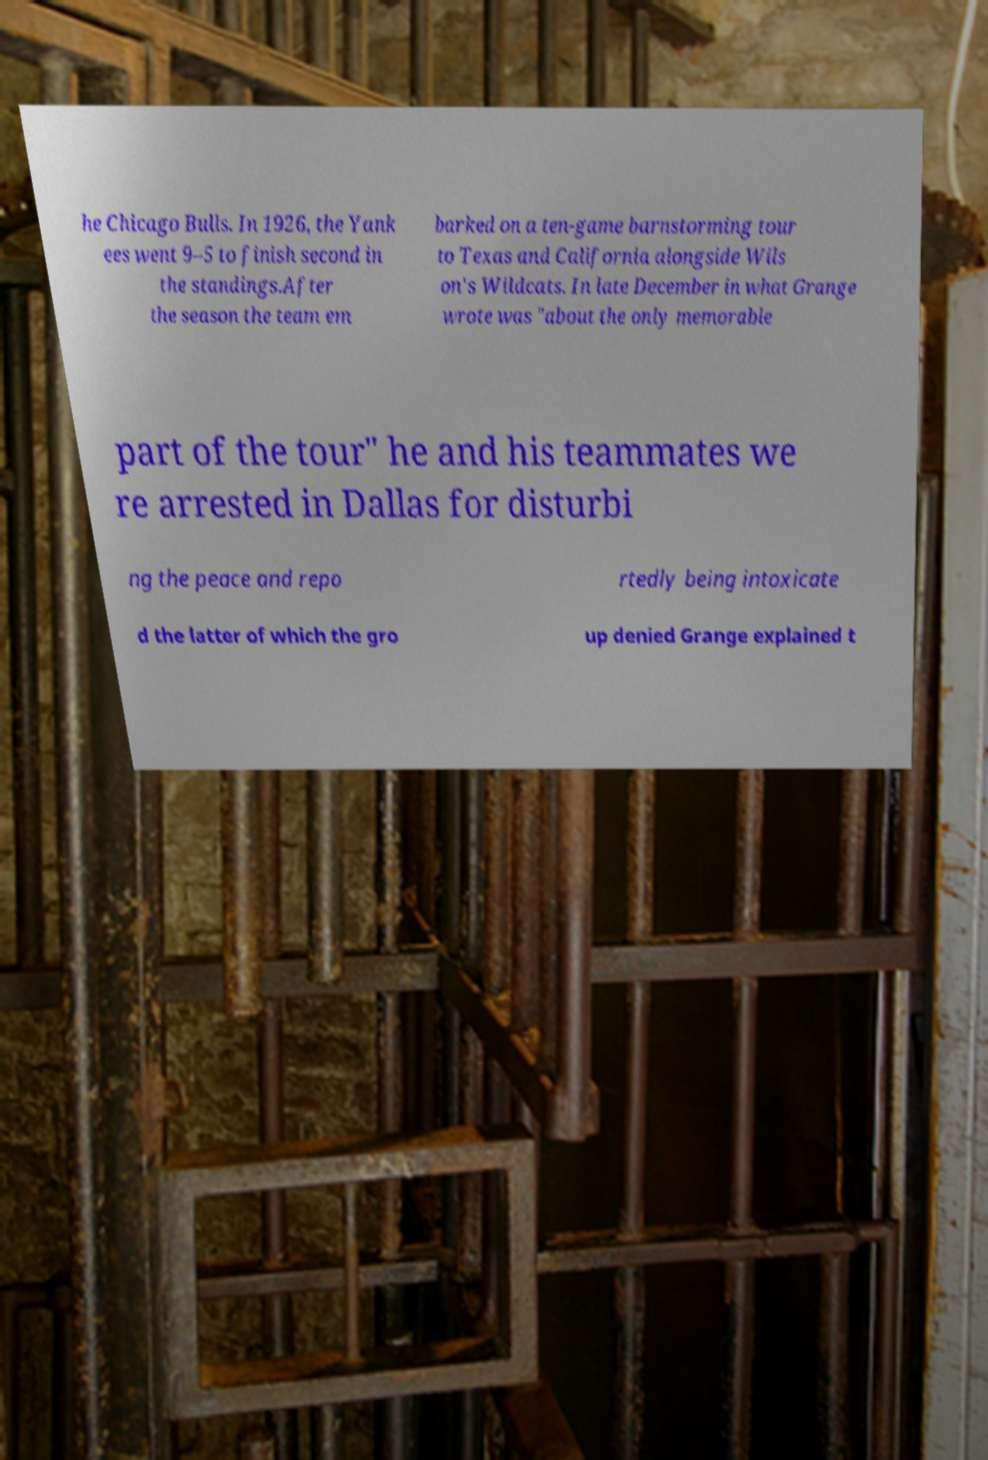Could you extract and type out the text from this image? he Chicago Bulls. In 1926, the Yank ees went 9–5 to finish second in the standings.After the season the team em barked on a ten-game barnstorming tour to Texas and California alongside Wils on's Wildcats. In late December in what Grange wrote was "about the only memorable part of the tour" he and his teammates we re arrested in Dallas for disturbi ng the peace and repo rtedly being intoxicate d the latter of which the gro up denied Grange explained t 